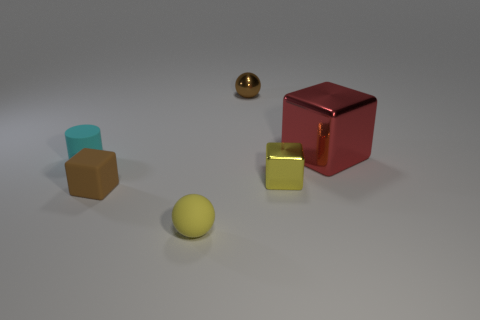Add 3 shiny things. How many objects exist? 9 Subtract all balls. How many objects are left? 4 Add 3 small metallic spheres. How many small metallic spheres are left? 4 Add 2 tiny yellow spheres. How many tiny yellow spheres exist? 3 Subtract 0 purple cylinders. How many objects are left? 6 Subtract all tiny gray rubber objects. Subtract all yellow metallic objects. How many objects are left? 5 